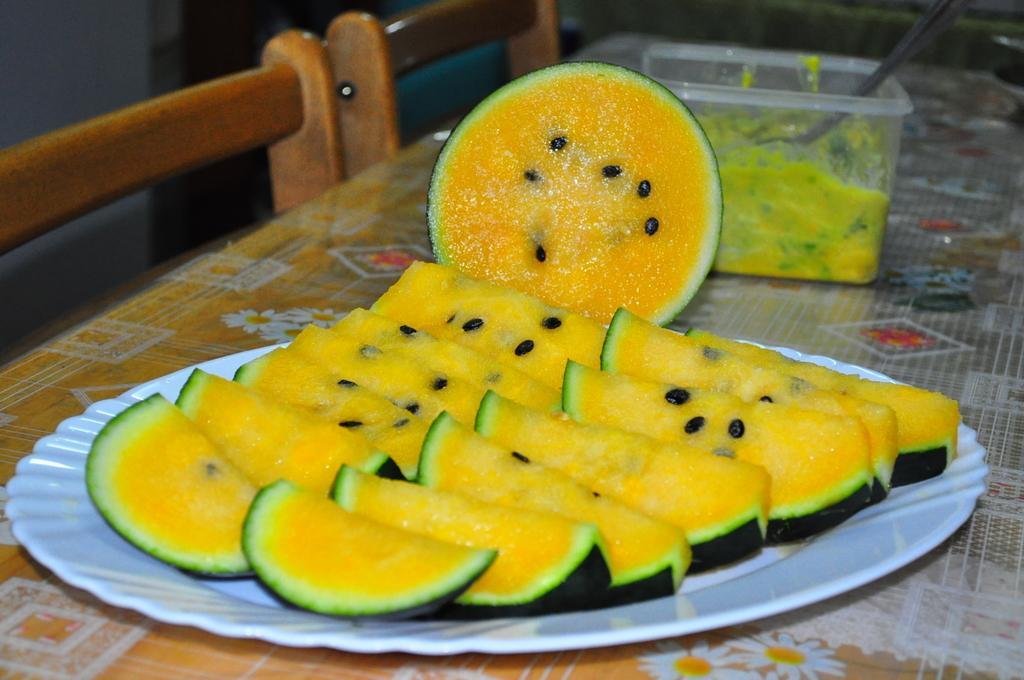How would you summarize this image in a sentence or two? In this image, we can see some food items in a plate and a box are placed on the table. We can also see some chairs. 